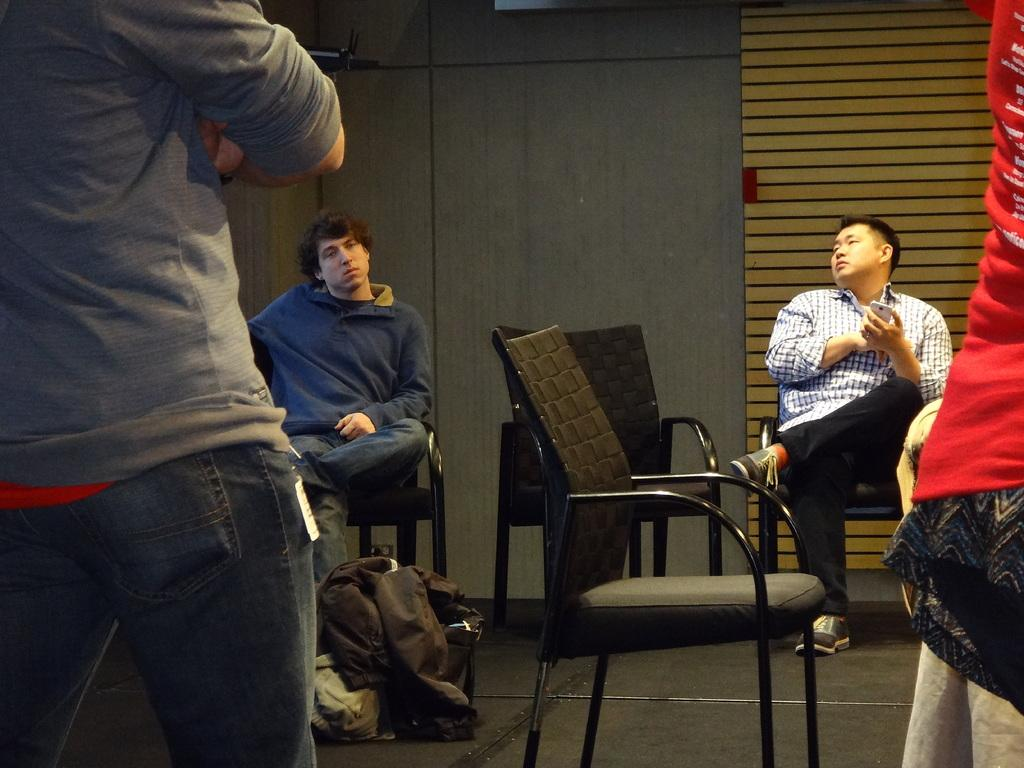How many people are sitting in chairs in the image? There are two men sitting in chairs in the image. What is the position of the third person in the image? One man is standing on the left side of the image. What can be seen in the background of the image? There is a wall in the background of the image. What type of part can be seen on the wall in the image? There is no mention of a part on the wall in the image. 